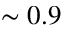Convert formula to latex. <formula><loc_0><loc_0><loc_500><loc_500>\sim 0 . 9</formula> 